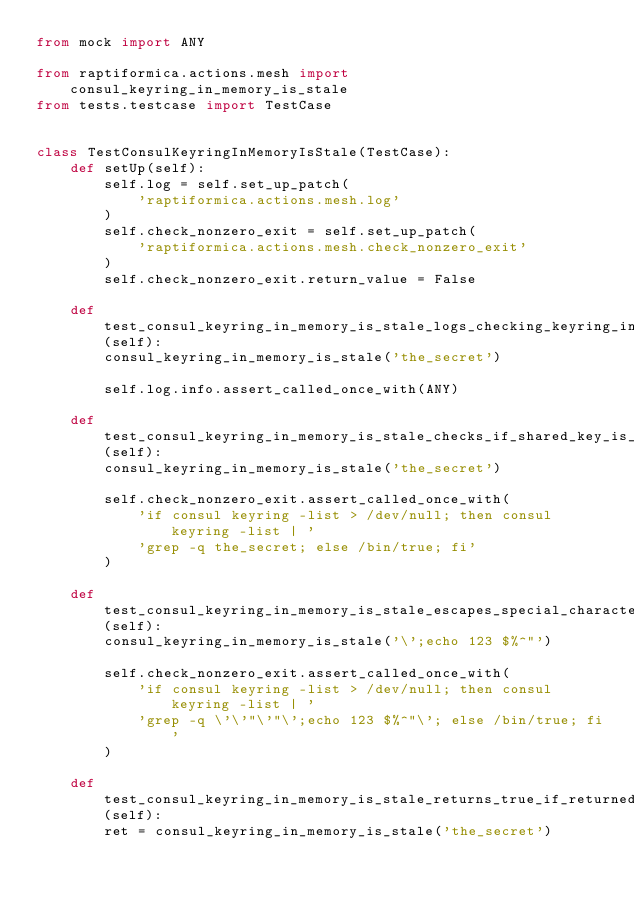Convert code to text. <code><loc_0><loc_0><loc_500><loc_500><_Python_>from mock import ANY

from raptiformica.actions.mesh import consul_keyring_in_memory_is_stale
from tests.testcase import TestCase


class TestConsulKeyringInMemoryIsStale(TestCase):
    def setUp(self):
        self.log = self.set_up_patch(
            'raptiformica.actions.mesh.log'
        )
        self.check_nonzero_exit = self.set_up_patch(
            'raptiformica.actions.mesh.check_nonzero_exit'
        )
        self.check_nonzero_exit.return_value = False

    def test_consul_keyring_in_memory_is_stale_logs_checking_keyring_in_memory_message(self):
        consul_keyring_in_memory_is_stale('the_secret')

        self.log.info.assert_called_once_with(ANY)

    def test_consul_keyring_in_memory_is_stale_checks_if_shared_key_is_in_memory(self):
        consul_keyring_in_memory_is_stale('the_secret')

        self.check_nonzero_exit.assert_called_once_with(
            'if consul keyring -list > /dev/null; then consul keyring -list | '
            'grep -q the_secret; else /bin/true; fi'
        )

    def test_consul_keyring_in_memory_is_stale_escapes_special_characters_in_shared_secret(self):
        consul_keyring_in_memory_is_stale('\';echo 123 $%^"')

        self.check_nonzero_exit.assert_called_once_with(
            'if consul keyring -list > /dev/null; then consul keyring -list | '
            'grep -q \'\'"\'"\';echo 123 $%^"\'; else /bin/true; fi'
        )

    def test_consul_keyring_in_memory_is_stale_returns_true_if_returned_nonzero(self):
        ret = consul_keyring_in_memory_is_stale('the_secret')
</code> 